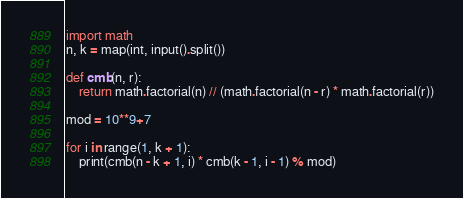Convert code to text. <code><loc_0><loc_0><loc_500><loc_500><_Python_>import math
n, k = map(int, input().split())

def cmb(n, r):
    return math.factorial(n) // (math.factorial(n - r) * math.factorial(r))

mod = 10**9+7

for i in range(1, k + 1):
    print(cmb(n - k + 1, i) * cmb(k - 1, i - 1) % mod)</code> 